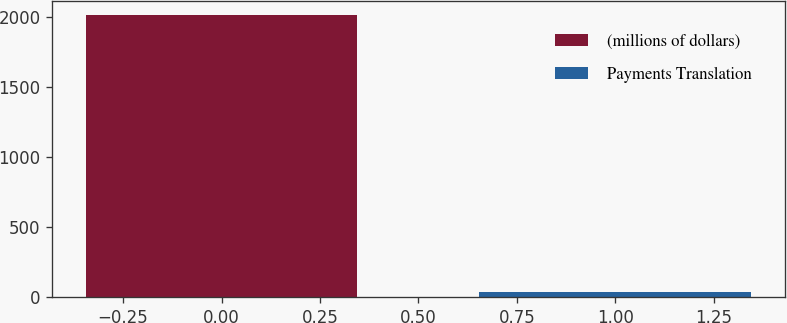Convert chart. <chart><loc_0><loc_0><loc_500><loc_500><bar_chart><fcel>(millions of dollars)<fcel>Payments Translation<nl><fcel>2013<fcel>36.7<nl></chart> 